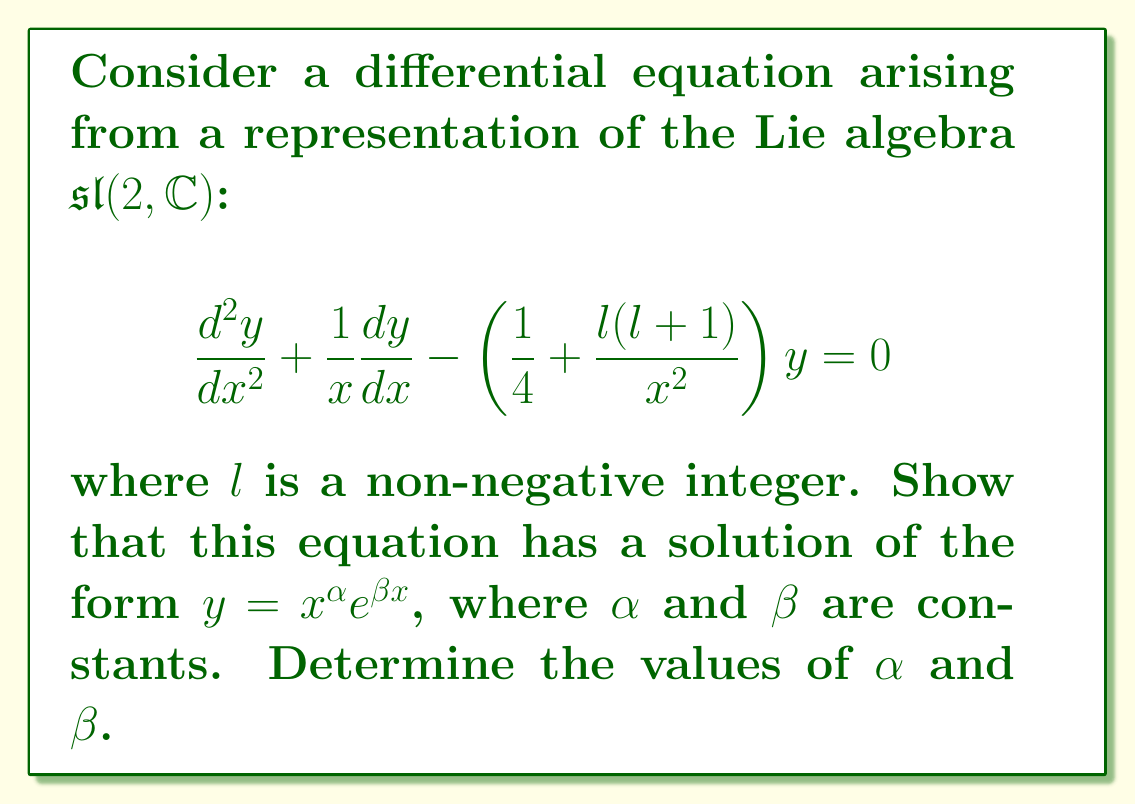Teach me how to tackle this problem. Let's approach this step-by-step:

1) We assume a solution of the form $y = x^{\alpha}e^{\beta x}$. We need to find $\frac{dy}{dx}$ and $\frac{d^2y}{dx^2}$.

2) First derivative:
   $$\frac{dy}{dx} = \alpha x^{\alpha-1}e^{\beta x} + \beta x^{\alpha}e^{\beta x}$$

3) Second derivative:
   $$\frac{d^2y}{dx^2} = \alpha(\alpha-1)x^{\alpha-2}e^{\beta x} + \alpha\beta x^{\alpha-1}e^{\beta x} + \beta\alpha x^{\alpha-1}e^{\beta x} + \beta^2 x^{\alpha}e^{\beta x}$$

4) Substitute these into the original equation:

   $$[\alpha(\alpha-1)x^{\alpha-2}e^{\beta x} + 2\alpha\beta x^{\alpha-1}e^{\beta x} + \beta^2 x^{\alpha}e^{\beta x}] + \frac{1}{x}[\alpha x^{\alpha-1}e^{\beta x} + \beta x^{\alpha}e^{\beta x}] - \left(\frac{1}{4} + \frac{l(l+1)}{x^2}\right)x^{\alpha}e^{\beta x} = 0$$

5) Simplify by dividing throughout by $x^{\alpha-2}e^{\beta x}$:

   $$\alpha(\alpha-1) + 2\alpha\beta x + \beta^2 x^2 + \alpha + \beta x - \frac{1}{4}x^2 - l(l+1) = 0$$

6) For this to be true for all $x$, the coefficients of each power of $x$ must be zero:

   $x^0$ term: $\alpha^2 - \alpha + \alpha - l(l+1) = 0$
   $x^1$ term: $2\alpha\beta + \beta = 0$
   $x^2$ term: $\beta^2 - \frac{1}{4} = 0$

7) From the $x^2$ term: $\beta = \pm \frac{1}{2}$

8) From the $x^1$ term: $\beta(2\alpha + 1) = 0$. Since $\beta \neq 0$, we must have $2\alpha + 1 = 0$, or $\alpha = -\frac{1}{2}$

9) Verify with the $x^0$ term: $(-\frac{1}{2})^2 - (-\frac{1}{2}) + (-\frac{1}{2}) - l(l+1) = 0$
   $\frac{1}{4} + \frac{1}{2} - \frac{1}{2} - l(l+1) = 0$
   $\frac{1}{4} = l(l+1)$

   This is true when $l = \frac{1}{2}$, which satisfies our condition that $l$ is a non-negative integer.

Therefore, we have found that $\alpha = -\frac{1}{2}$ and $\beta = \pm \frac{1}{2}$.
Answer: $\alpha = -\frac{1}{2}$, $\beta = \pm \frac{1}{2}$ 